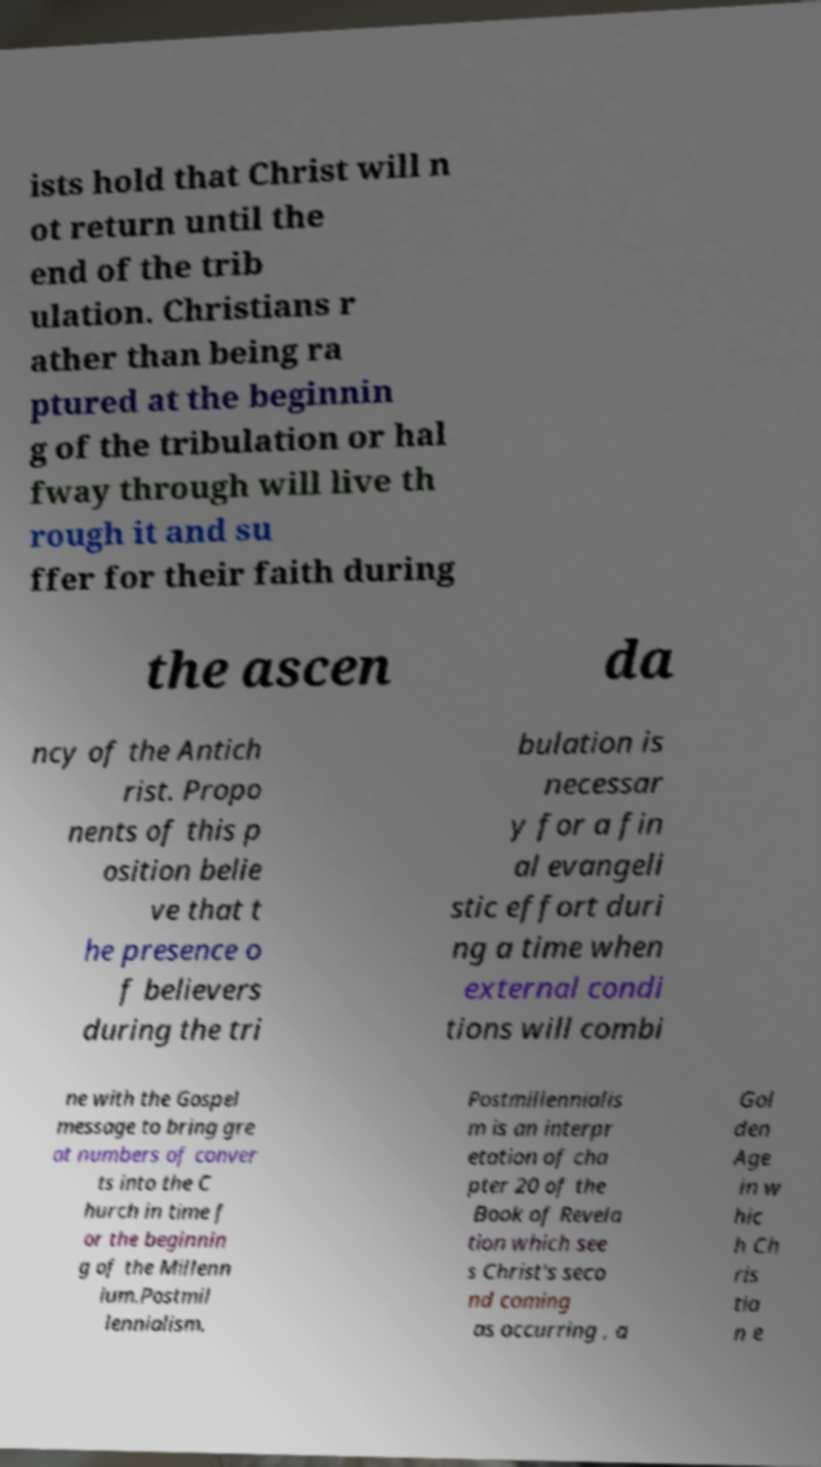What messages or text are displayed in this image? I need them in a readable, typed format. ists hold that Christ will n ot return until the end of the trib ulation. Christians r ather than being ra ptured at the beginnin g of the tribulation or hal fway through will live th rough it and su ffer for their faith during the ascen da ncy of the Antich rist. Propo nents of this p osition belie ve that t he presence o f believers during the tri bulation is necessar y for a fin al evangeli stic effort duri ng a time when external condi tions will combi ne with the Gospel message to bring gre at numbers of conver ts into the C hurch in time f or the beginnin g of the Millenn ium.Postmil lennialism. Postmillennialis m is an interpr etation of cha pter 20 of the Book of Revela tion which see s Christ's seco nd coming as occurring , a Gol den Age in w hic h Ch ris tia n e 